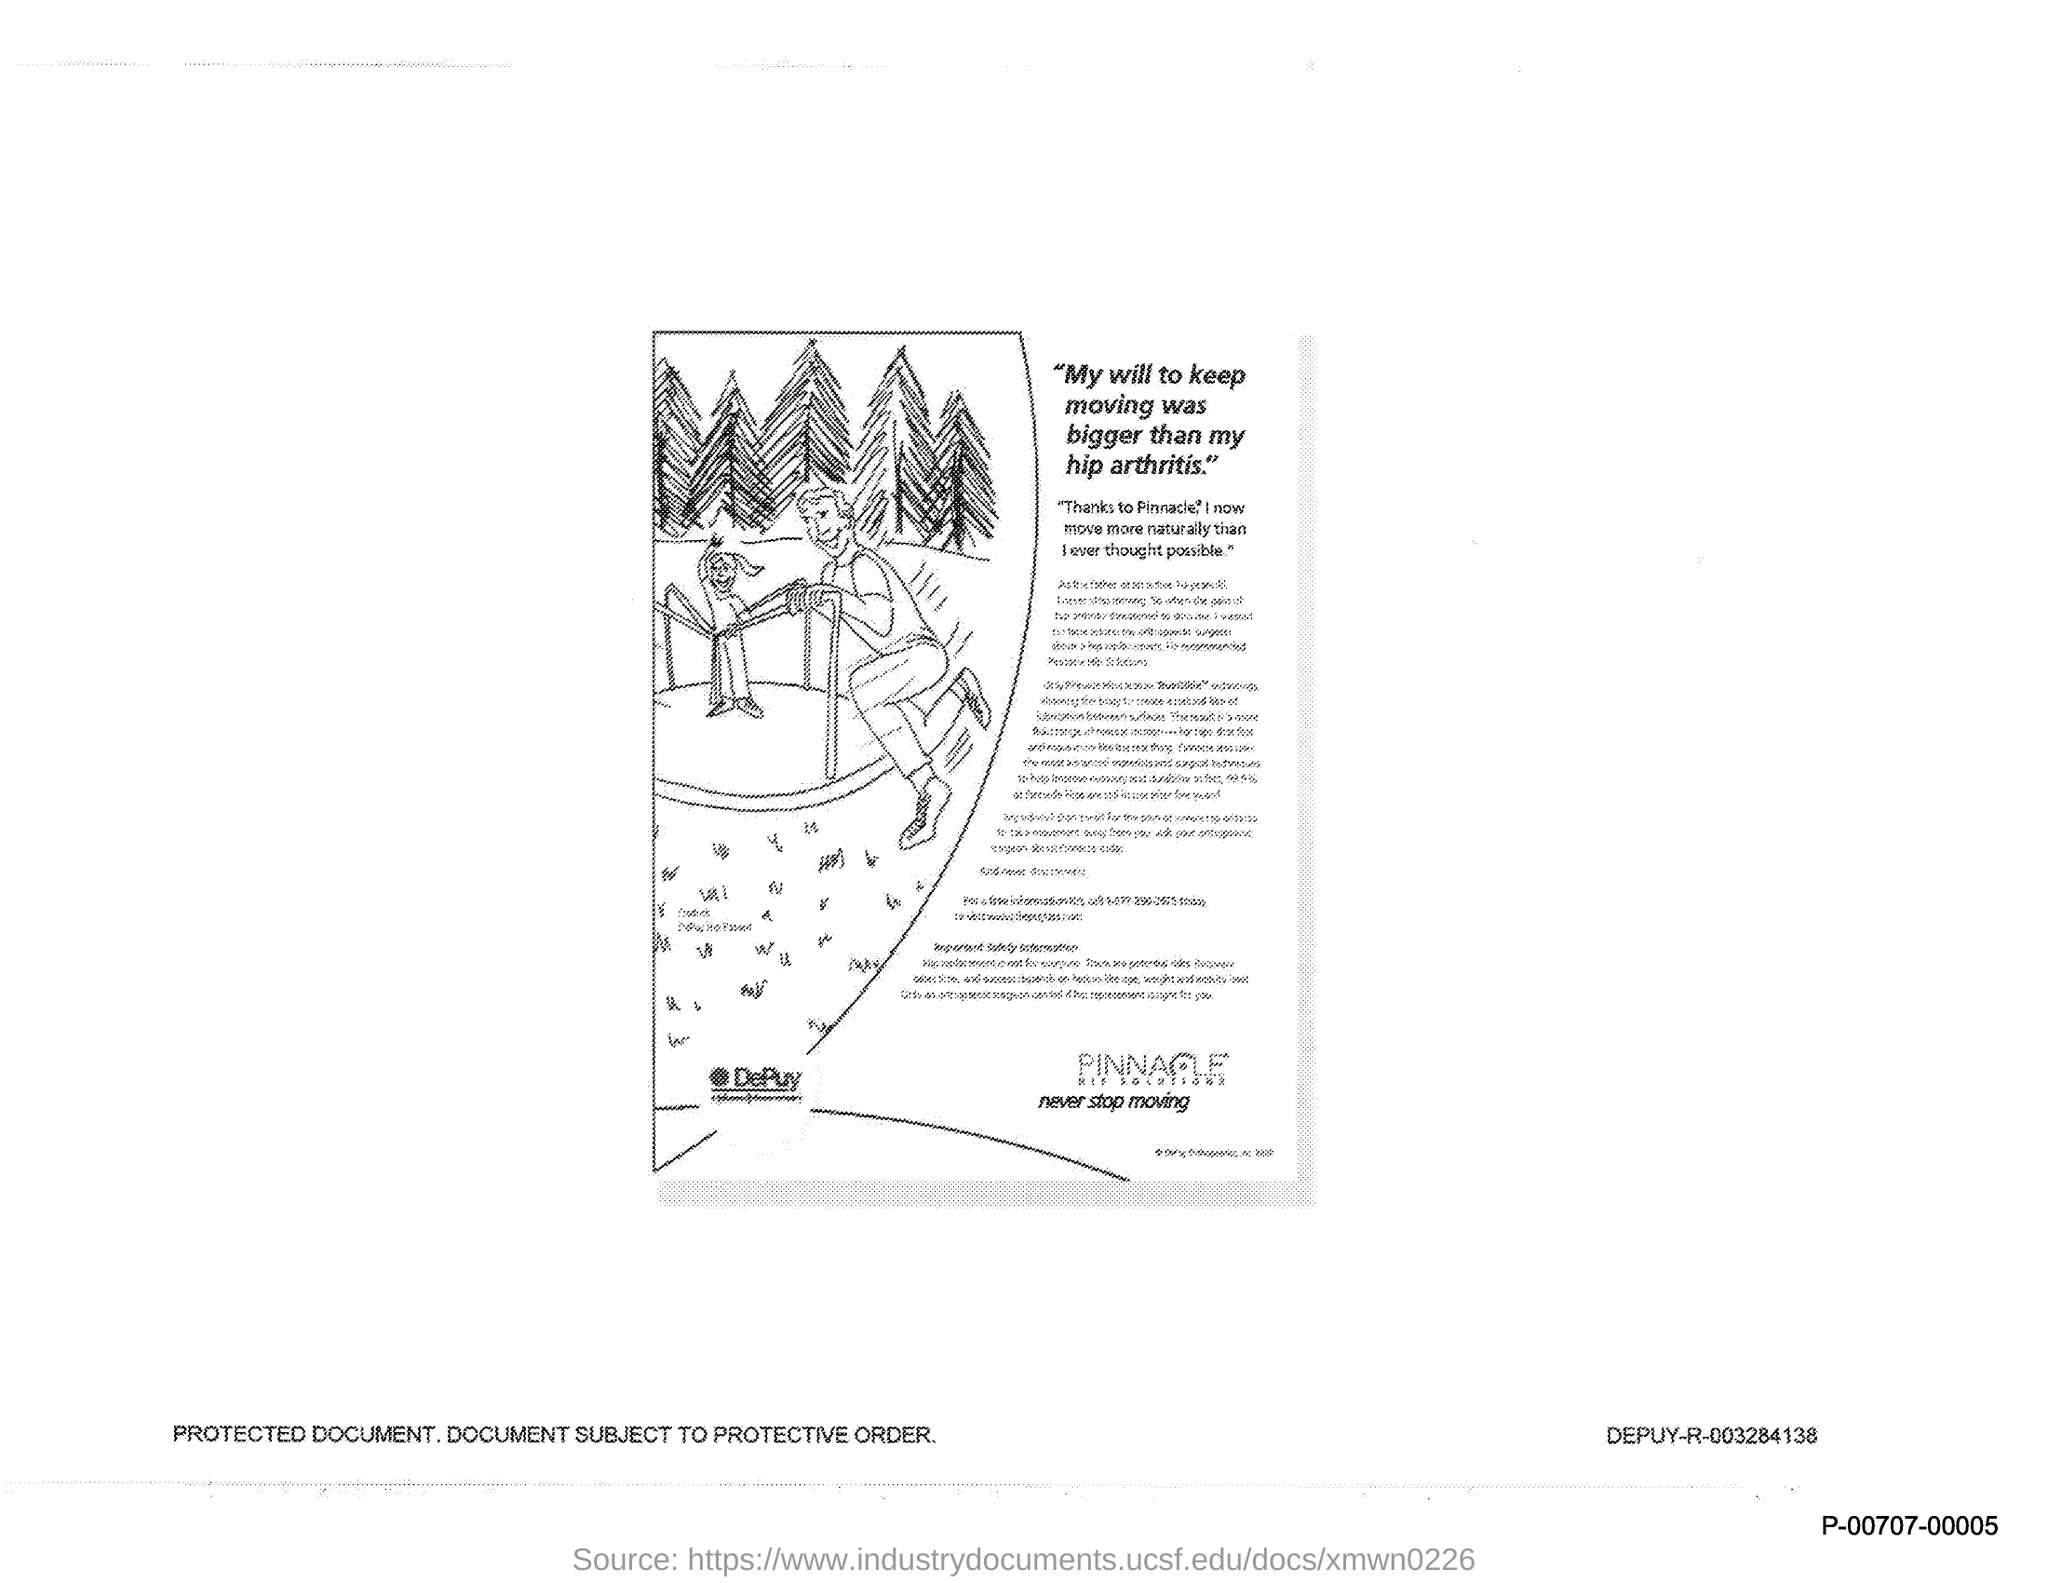What is the first title in the document?
Your answer should be very brief. "My will to keep moving was bigger than my hip arthritis.". 